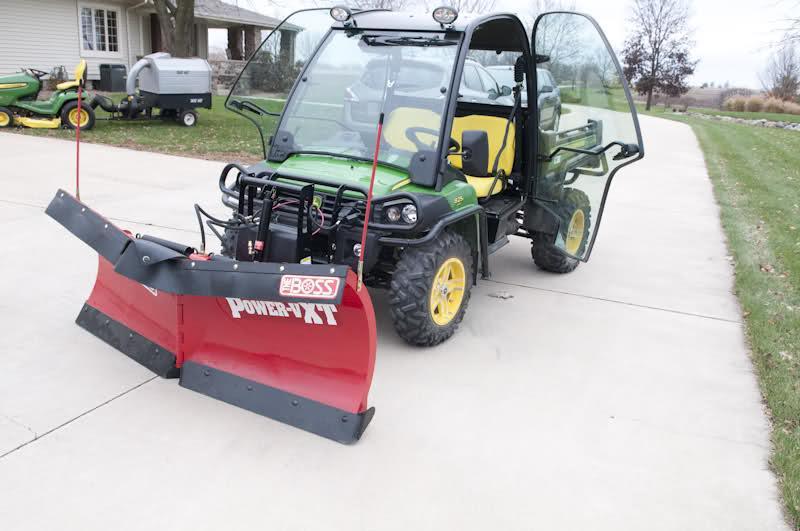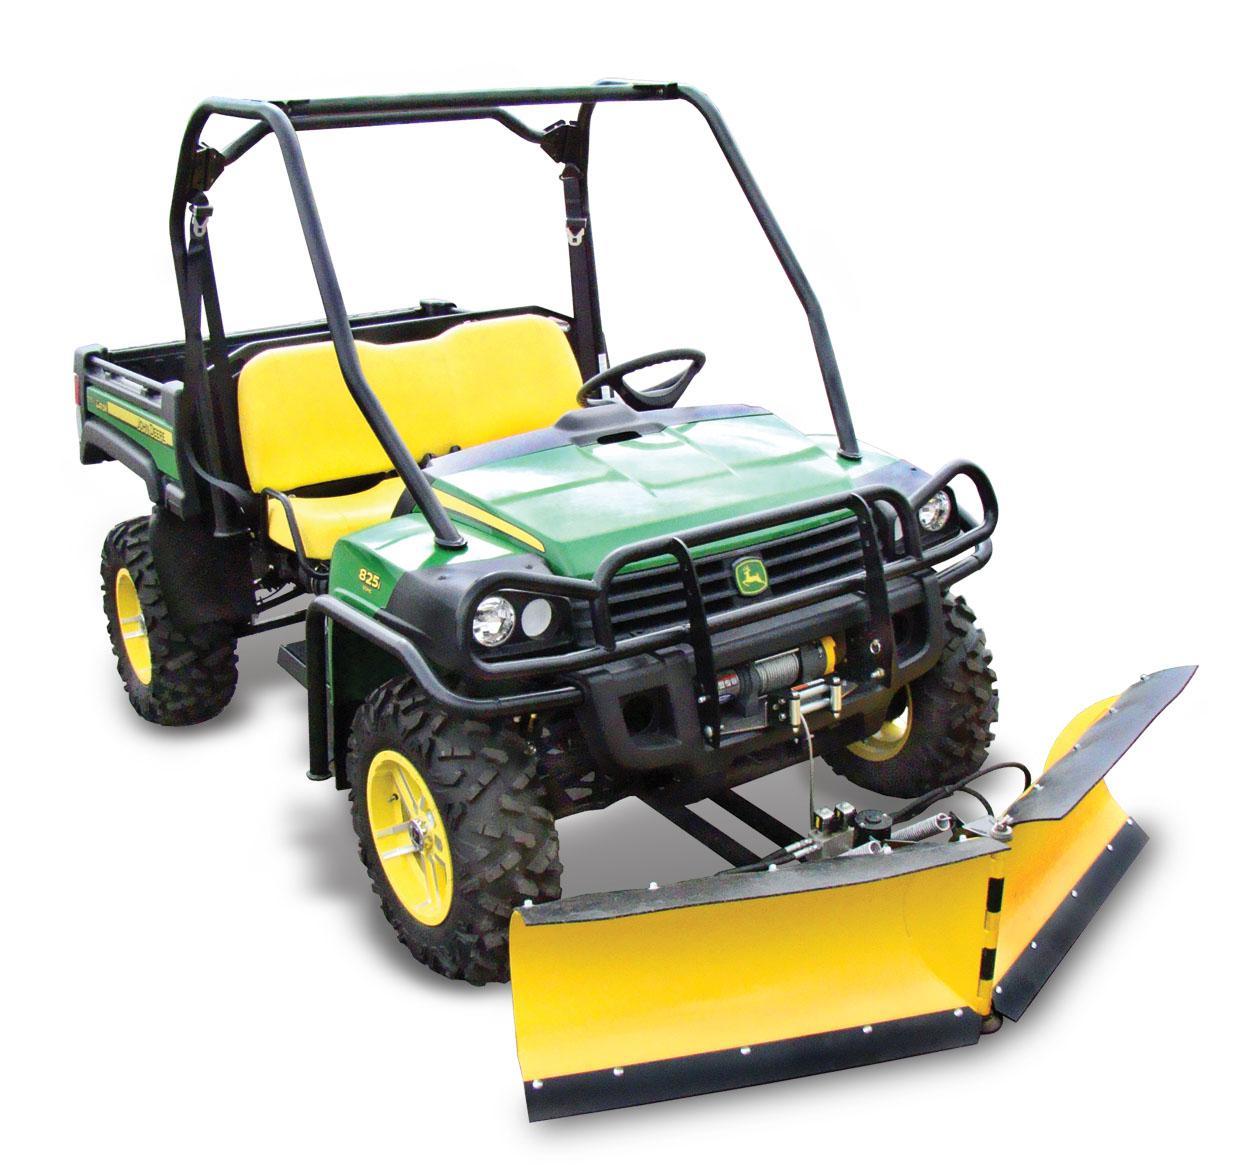The first image is the image on the left, the second image is the image on the right. Given the left and right images, does the statement "One image features a vehicle with a red plow." hold true? Answer yes or no. Yes. 